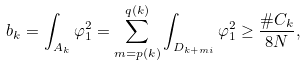<formula> <loc_0><loc_0><loc_500><loc_500>b _ { k } = \int _ { A _ { k } } \varphi _ { 1 } ^ { 2 } = \sum _ { m = p ( k ) } ^ { q ( k ) } \int _ { D _ { k + m i } } \varphi _ { 1 } ^ { 2 } \geq \frac { \# C _ { k } } { 8 N } ,</formula> 